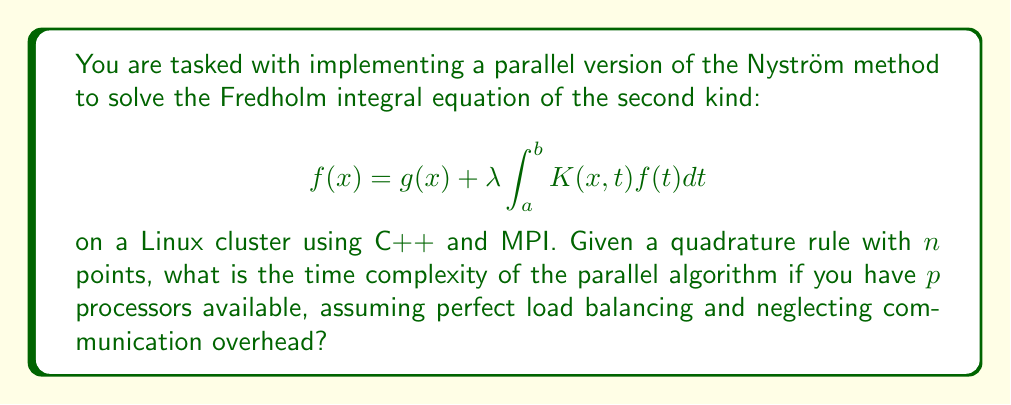Can you answer this question? Let's break this down step-by-step:

1) The Nyström method for solving Fredholm integral equations involves discretizing the integral using a quadrature rule. This transforms the integral equation into a system of linear equations.

2) For $n$ quadrature points, we end up with an $n \times n$ system of linear equations.

3) The main computational steps in the Nyström method are:
   a) Evaluating the kernel $K(x_i, x_j)$ for all pairs of quadrature points: $O(n^2)$
   b) Solving the resulting linear system: $O(n^3)$ for direct methods like Gaussian elimination

4) In a parallel environment with $p$ processors:
   a) The kernel evaluation can be divided among processors, reducing the time to $O(n^2/p)$
   b) The linear system solution can use parallel algorithms, typically reducing time to $O(n^3/p)$

5) The overall time complexity is dominated by the linear system solution.

6) Therefore, the time complexity of the parallel Nyström method with $p$ processors is $O(n^3/p)$.

This assumes perfect load balancing and neglects communication overhead, as specified in the question.
Answer: $O(n^3/p)$ 